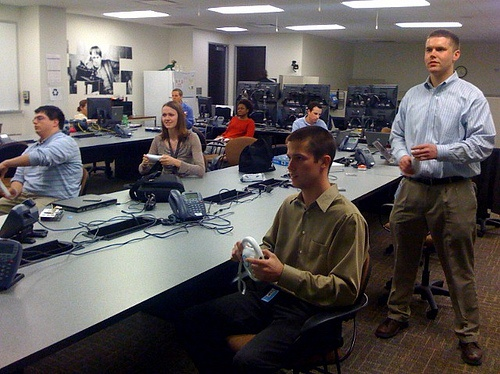Describe the objects in this image and their specific colors. I can see people in gray, black, and maroon tones, people in gray, black, darkgray, lavender, and maroon tones, people in gray, darkgray, and black tones, people in gray, black, and maroon tones, and chair in gray and black tones in this image. 